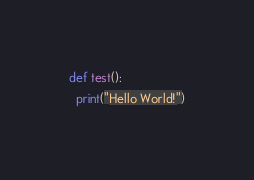Convert code to text. <code><loc_0><loc_0><loc_500><loc_500><_Python_>def test():
  print("Hello World!")</code> 